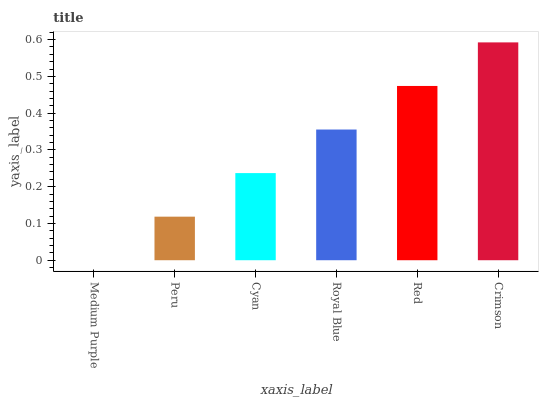Is Medium Purple the minimum?
Answer yes or no. Yes. Is Crimson the maximum?
Answer yes or no. Yes. Is Peru the minimum?
Answer yes or no. No. Is Peru the maximum?
Answer yes or no. No. Is Peru greater than Medium Purple?
Answer yes or no. Yes. Is Medium Purple less than Peru?
Answer yes or no. Yes. Is Medium Purple greater than Peru?
Answer yes or no. No. Is Peru less than Medium Purple?
Answer yes or no. No. Is Royal Blue the high median?
Answer yes or no. Yes. Is Cyan the low median?
Answer yes or no. Yes. Is Medium Purple the high median?
Answer yes or no. No. Is Royal Blue the low median?
Answer yes or no. No. 